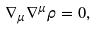Convert formula to latex. <formula><loc_0><loc_0><loc_500><loc_500>\nabla _ { \mu } \nabla ^ { \mu } \rho = 0 ,</formula> 